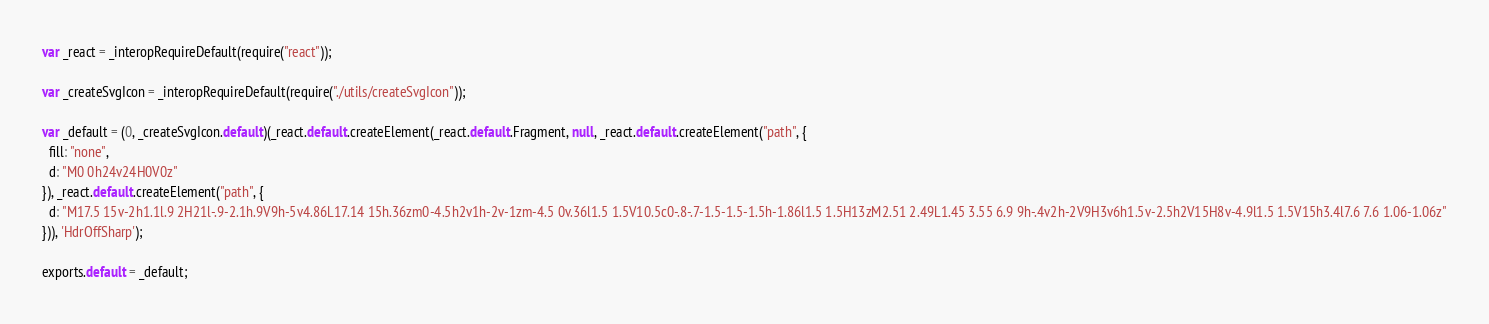<code> <loc_0><loc_0><loc_500><loc_500><_JavaScript_>
var _react = _interopRequireDefault(require("react"));

var _createSvgIcon = _interopRequireDefault(require("./utils/createSvgIcon"));

var _default = (0, _createSvgIcon.default)(_react.default.createElement(_react.default.Fragment, null, _react.default.createElement("path", {
  fill: "none",
  d: "M0 0h24v24H0V0z"
}), _react.default.createElement("path", {
  d: "M17.5 15v-2h1.1l.9 2H21l-.9-2.1h.9V9h-5v4.86L17.14 15h.36zm0-4.5h2v1h-2v-1zm-4.5 0v.36l1.5 1.5V10.5c0-.8-.7-1.5-1.5-1.5h-1.86l1.5 1.5H13zM2.51 2.49L1.45 3.55 6.9 9h-.4v2h-2V9H3v6h1.5v-2.5h2V15H8v-4.9l1.5 1.5V15h3.4l7.6 7.6 1.06-1.06z"
})), 'HdrOffSharp');

exports.default = _default;</code> 